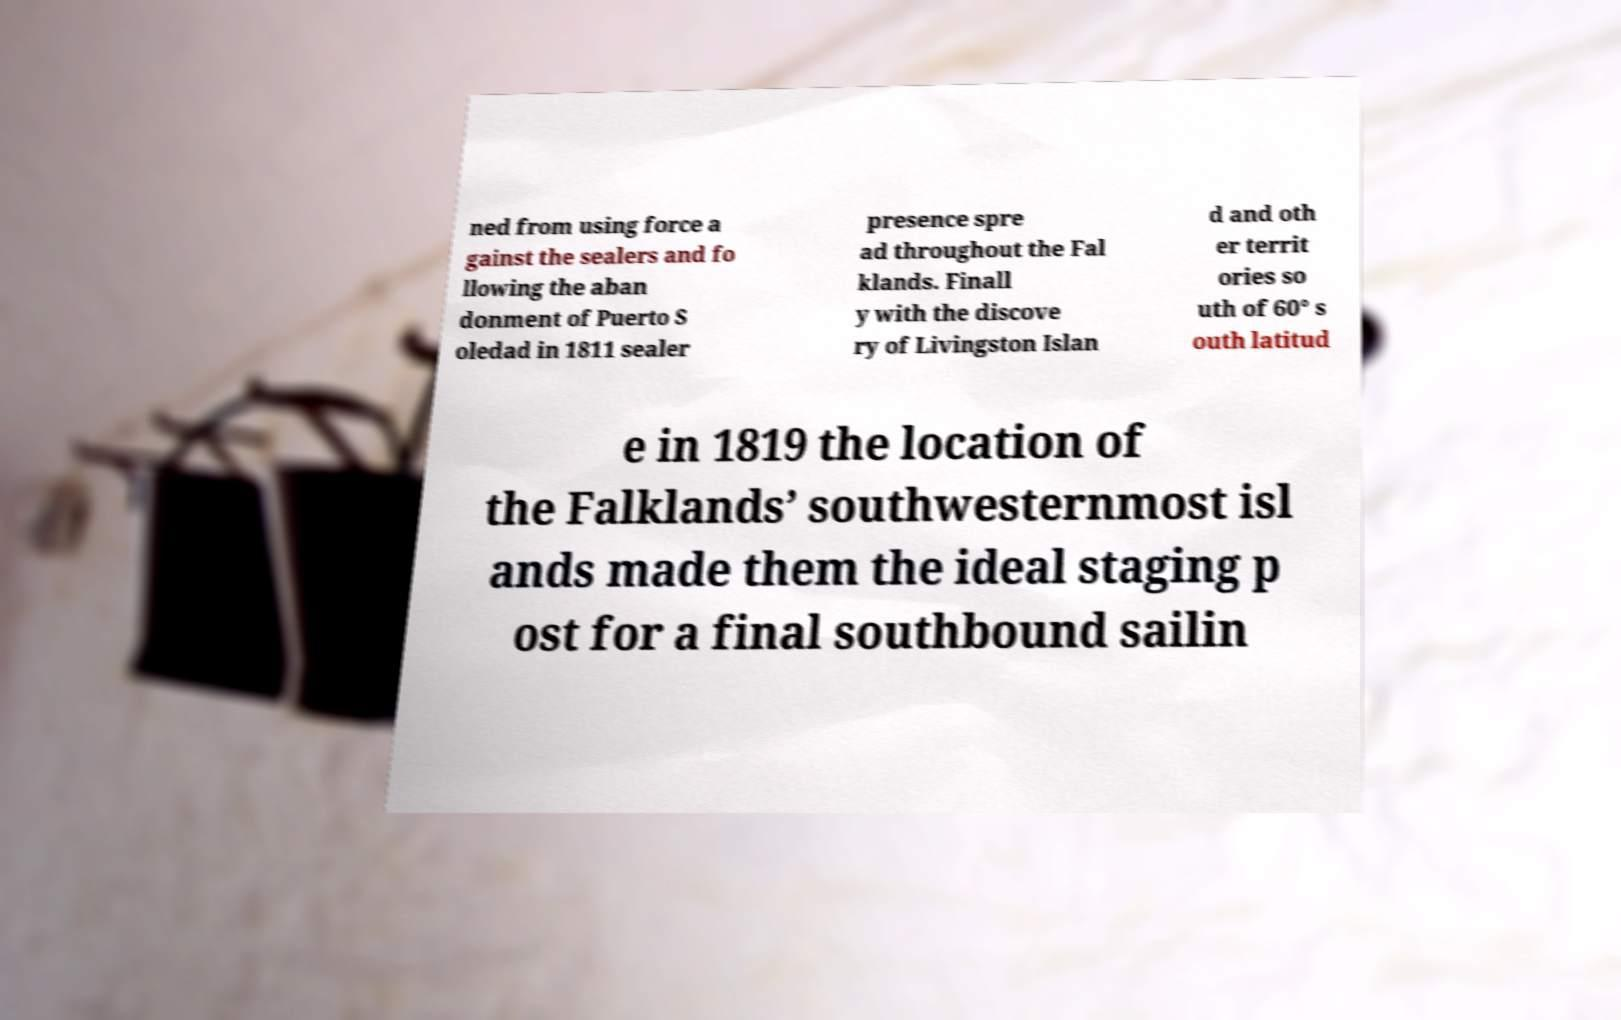I need the written content from this picture converted into text. Can you do that? ned from using force a gainst the sealers and fo llowing the aban donment of Puerto S oledad in 1811 sealer presence spre ad throughout the Fal klands. Finall y with the discove ry of Livingston Islan d and oth er territ ories so uth of 60° s outh latitud e in 1819 the location of the Falklands’ southwesternmost isl ands made them the ideal staging p ost for a final southbound sailin 